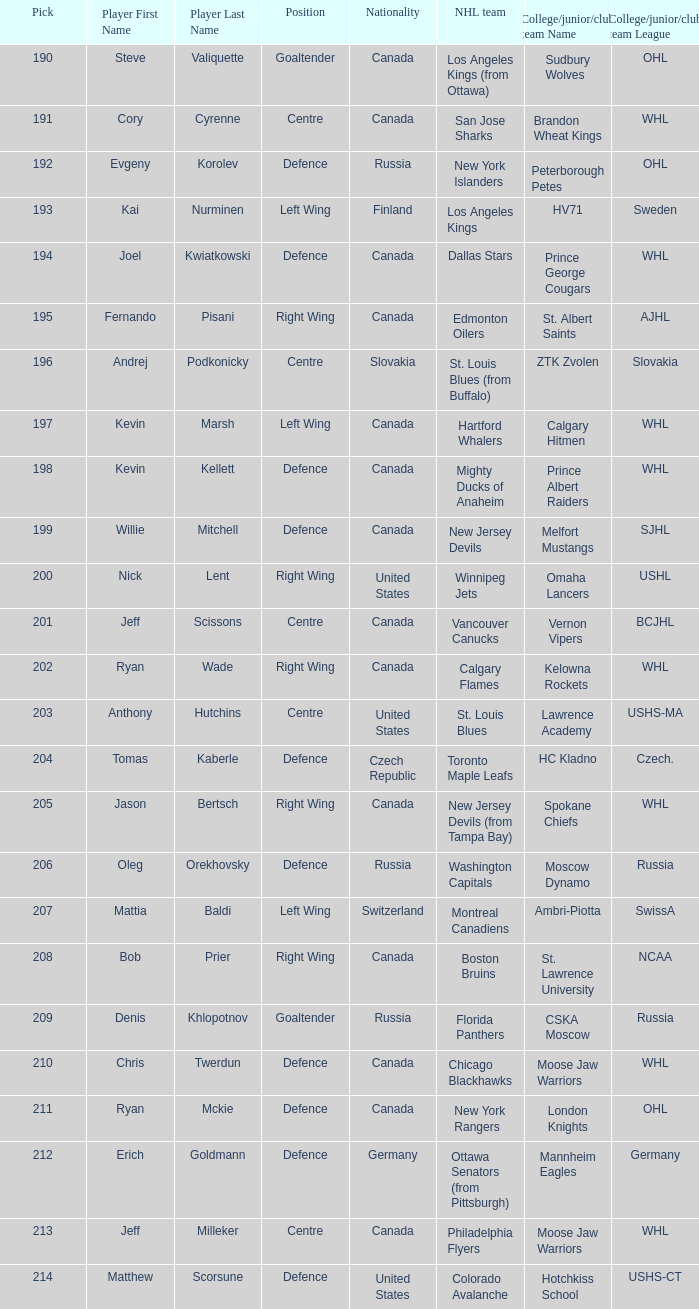Name the college for andrej podkonicky ZTK Zvolen (Slovakia). 